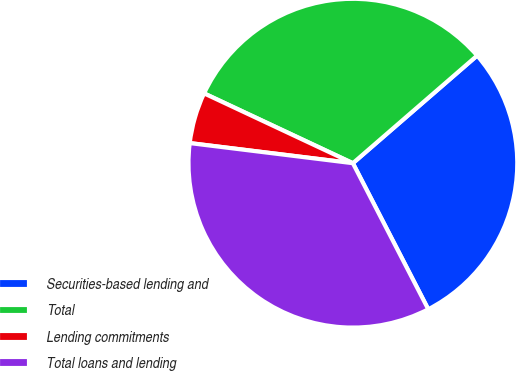Convert chart to OTSL. <chart><loc_0><loc_0><loc_500><loc_500><pie_chart><fcel>Securities-based lending and<fcel>Total<fcel>Lending commitments<fcel>Total loans and lending<nl><fcel>28.78%<fcel>31.66%<fcel>5.03%<fcel>34.54%<nl></chart> 